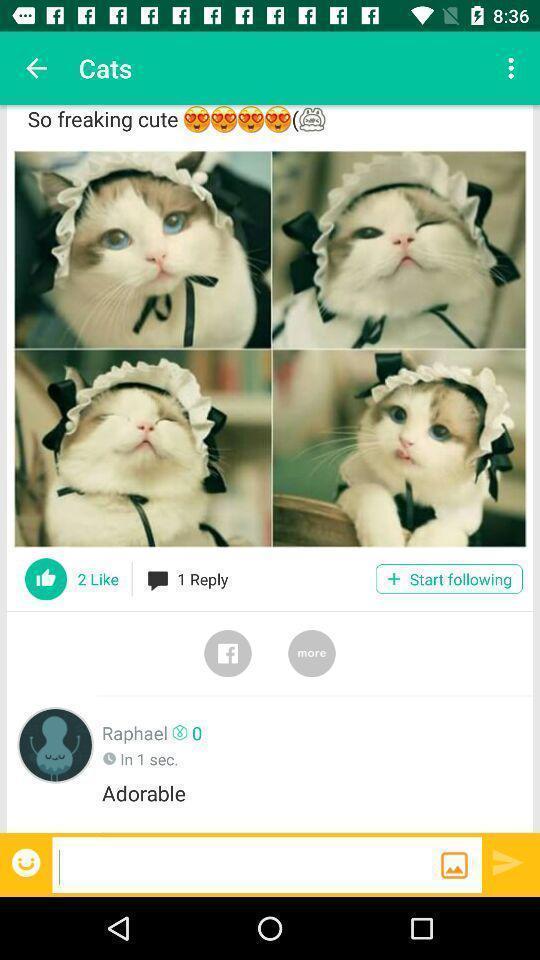Provide a textual representation of this image. Page showing few pictures and options. 